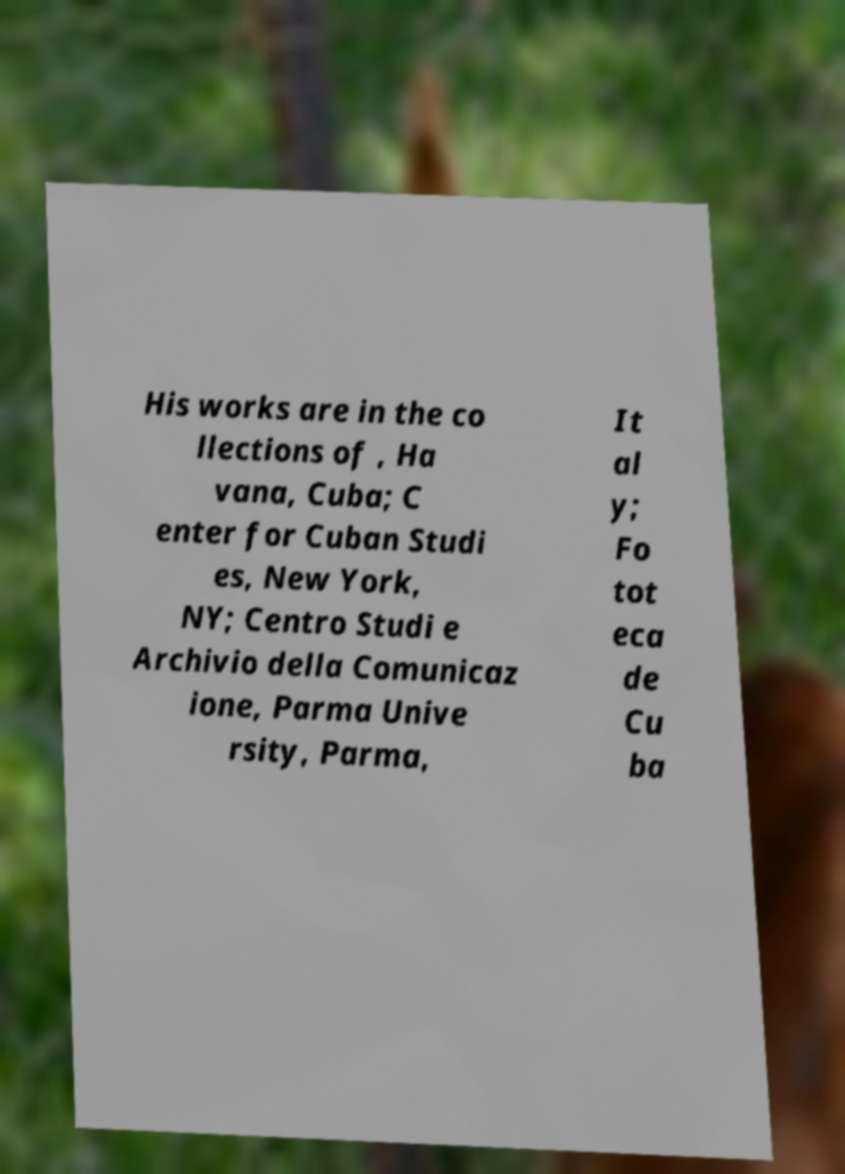Could you extract and type out the text from this image? His works are in the co llections of , Ha vana, Cuba; C enter for Cuban Studi es, New York, NY; Centro Studi e Archivio della Comunicaz ione, Parma Unive rsity, Parma, It al y; Fo tot eca de Cu ba 